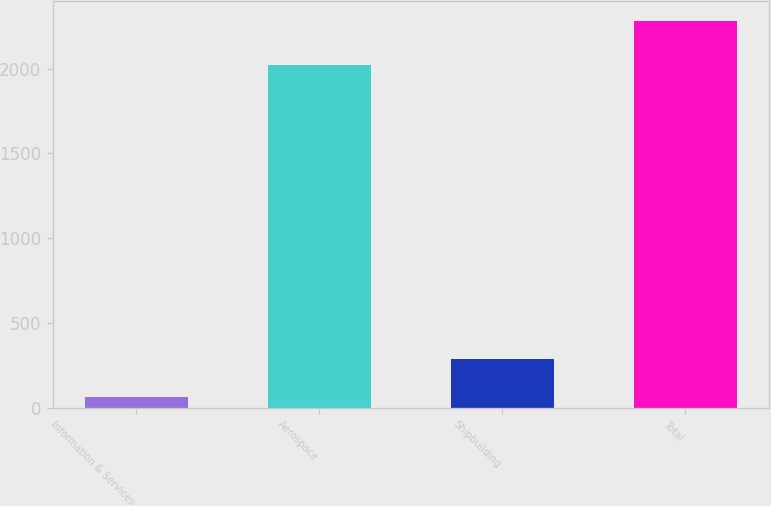Convert chart. <chart><loc_0><loc_0><loc_500><loc_500><bar_chart><fcel>Information & Services<fcel>Aerospace<fcel>Shipbuilding<fcel>Total<nl><fcel>62<fcel>2023<fcel>284<fcel>2282<nl></chart> 